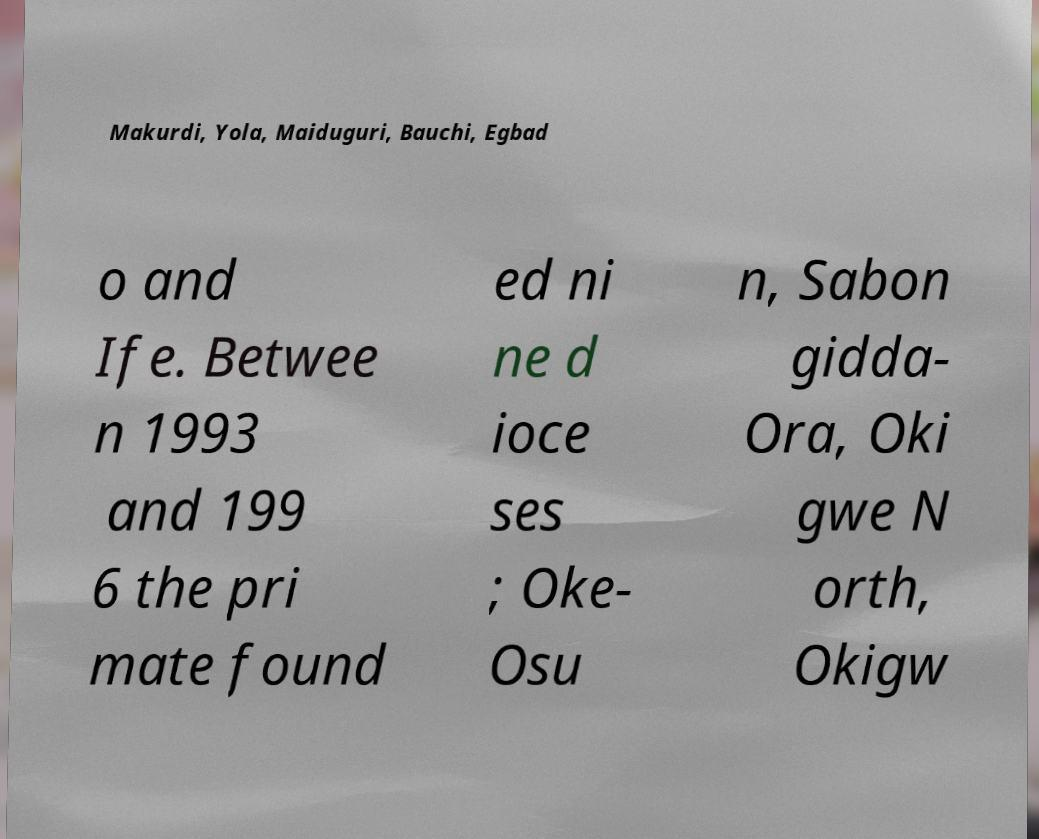Could you assist in decoding the text presented in this image and type it out clearly? Makurdi, Yola, Maiduguri, Bauchi, Egbad o and Ife. Betwee n 1993 and 199 6 the pri mate found ed ni ne d ioce ses ; Oke- Osu n, Sabon gidda- Ora, Oki gwe N orth, Okigw 